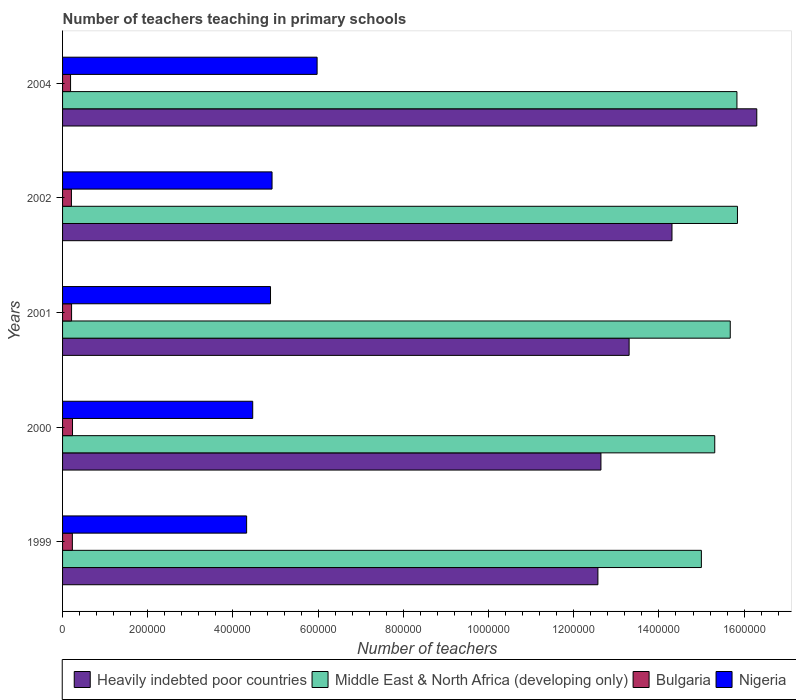Are the number of bars per tick equal to the number of legend labels?
Your answer should be very brief. Yes. Are the number of bars on each tick of the Y-axis equal?
Offer a very short reply. Yes. How many bars are there on the 3rd tick from the bottom?
Offer a very short reply. 4. What is the label of the 1st group of bars from the top?
Ensure brevity in your answer.  2004. In how many cases, is the number of bars for a given year not equal to the number of legend labels?
Your answer should be compact. 0. What is the number of teachers teaching in primary schools in Nigeria in 2004?
Keep it short and to the point. 5.98e+05. Across all years, what is the maximum number of teachers teaching in primary schools in Middle East & North Africa (developing only)?
Provide a succinct answer. 1.58e+06. Across all years, what is the minimum number of teachers teaching in primary schools in Nigeria?
Your answer should be compact. 4.32e+05. In which year was the number of teachers teaching in primary schools in Bulgaria maximum?
Offer a very short reply. 2000. In which year was the number of teachers teaching in primary schools in Heavily indebted poor countries minimum?
Your answer should be very brief. 1999. What is the total number of teachers teaching in primary schools in Nigeria in the graph?
Your response must be concise. 2.46e+06. What is the difference between the number of teachers teaching in primary schools in Middle East & North Africa (developing only) in 1999 and that in 2000?
Provide a succinct answer. -3.14e+04. What is the difference between the number of teachers teaching in primary schools in Middle East & North Africa (developing only) in 2004 and the number of teachers teaching in primary schools in Nigeria in 2001?
Your response must be concise. 1.09e+06. What is the average number of teachers teaching in primary schools in Bulgaria per year?
Offer a very short reply. 2.14e+04. In the year 2001, what is the difference between the number of teachers teaching in primary schools in Nigeria and number of teachers teaching in primary schools in Bulgaria?
Your response must be concise. 4.67e+05. What is the ratio of the number of teachers teaching in primary schools in Heavily indebted poor countries in 1999 to that in 2004?
Ensure brevity in your answer.  0.77. Is the number of teachers teaching in primary schools in Heavily indebted poor countries in 2000 less than that in 2004?
Provide a short and direct response. Yes. Is the difference between the number of teachers teaching in primary schools in Nigeria in 2000 and 2004 greater than the difference between the number of teachers teaching in primary schools in Bulgaria in 2000 and 2004?
Offer a terse response. No. What is the difference between the highest and the second highest number of teachers teaching in primary schools in Bulgaria?
Keep it short and to the point. 361. What is the difference between the highest and the lowest number of teachers teaching in primary schools in Middle East & North Africa (developing only)?
Give a very brief answer. 8.47e+04. In how many years, is the number of teachers teaching in primary schools in Bulgaria greater than the average number of teachers teaching in primary schools in Bulgaria taken over all years?
Keep it short and to the point. 2. What does the 4th bar from the top in 2000 represents?
Ensure brevity in your answer.  Heavily indebted poor countries. What does the 4th bar from the bottom in 2000 represents?
Your answer should be very brief. Nigeria. Is it the case that in every year, the sum of the number of teachers teaching in primary schools in Middle East & North Africa (developing only) and number of teachers teaching in primary schools in Nigeria is greater than the number of teachers teaching in primary schools in Heavily indebted poor countries?
Give a very brief answer. Yes. Does the graph contain grids?
Make the answer very short. No. Where does the legend appear in the graph?
Give a very brief answer. Bottom right. How many legend labels are there?
Provide a short and direct response. 4. What is the title of the graph?
Your answer should be very brief. Number of teachers teaching in primary schools. What is the label or title of the X-axis?
Provide a succinct answer. Number of teachers. What is the label or title of the Y-axis?
Offer a terse response. Years. What is the Number of teachers of Heavily indebted poor countries in 1999?
Offer a very short reply. 1.26e+06. What is the Number of teachers of Middle East & North Africa (developing only) in 1999?
Ensure brevity in your answer.  1.50e+06. What is the Number of teachers in Bulgaria in 1999?
Give a very brief answer. 2.30e+04. What is the Number of teachers of Nigeria in 1999?
Keep it short and to the point. 4.32e+05. What is the Number of teachers in Heavily indebted poor countries in 2000?
Provide a succinct answer. 1.26e+06. What is the Number of teachers in Middle East & North Africa (developing only) in 2000?
Provide a succinct answer. 1.53e+06. What is the Number of teachers in Bulgaria in 2000?
Provide a short and direct response. 2.33e+04. What is the Number of teachers of Nigeria in 2000?
Make the answer very short. 4.46e+05. What is the Number of teachers of Heavily indebted poor countries in 2001?
Give a very brief answer. 1.33e+06. What is the Number of teachers of Middle East & North Africa (developing only) in 2001?
Offer a very short reply. 1.57e+06. What is the Number of teachers in Bulgaria in 2001?
Your answer should be compact. 2.12e+04. What is the Number of teachers of Nigeria in 2001?
Your response must be concise. 4.88e+05. What is the Number of teachers of Heavily indebted poor countries in 2002?
Give a very brief answer. 1.43e+06. What is the Number of teachers of Middle East & North Africa (developing only) in 2002?
Give a very brief answer. 1.58e+06. What is the Number of teachers of Bulgaria in 2002?
Provide a short and direct response. 2.08e+04. What is the Number of teachers of Nigeria in 2002?
Offer a terse response. 4.92e+05. What is the Number of teachers in Heavily indebted poor countries in 2004?
Provide a succinct answer. 1.63e+06. What is the Number of teachers in Middle East & North Africa (developing only) in 2004?
Make the answer very short. 1.58e+06. What is the Number of teachers in Bulgaria in 2004?
Your answer should be compact. 1.88e+04. What is the Number of teachers in Nigeria in 2004?
Ensure brevity in your answer.  5.98e+05. Across all years, what is the maximum Number of teachers of Heavily indebted poor countries?
Ensure brevity in your answer.  1.63e+06. Across all years, what is the maximum Number of teachers in Middle East & North Africa (developing only)?
Your answer should be very brief. 1.58e+06. Across all years, what is the maximum Number of teachers in Bulgaria?
Provide a succinct answer. 2.33e+04. Across all years, what is the maximum Number of teachers of Nigeria?
Your answer should be compact. 5.98e+05. Across all years, what is the minimum Number of teachers of Heavily indebted poor countries?
Offer a terse response. 1.26e+06. Across all years, what is the minimum Number of teachers of Middle East & North Africa (developing only)?
Make the answer very short. 1.50e+06. Across all years, what is the minimum Number of teachers in Bulgaria?
Make the answer very short. 1.88e+04. Across all years, what is the minimum Number of teachers of Nigeria?
Make the answer very short. 4.32e+05. What is the total Number of teachers of Heavily indebted poor countries in the graph?
Your answer should be very brief. 6.91e+06. What is the total Number of teachers in Middle East & North Africa (developing only) in the graph?
Keep it short and to the point. 7.77e+06. What is the total Number of teachers of Bulgaria in the graph?
Your response must be concise. 1.07e+05. What is the total Number of teachers in Nigeria in the graph?
Keep it short and to the point. 2.46e+06. What is the difference between the Number of teachers of Heavily indebted poor countries in 1999 and that in 2000?
Give a very brief answer. -7112.5. What is the difference between the Number of teachers of Middle East & North Africa (developing only) in 1999 and that in 2000?
Your response must be concise. -3.14e+04. What is the difference between the Number of teachers in Bulgaria in 1999 and that in 2000?
Your answer should be compact. -361. What is the difference between the Number of teachers of Nigeria in 1999 and that in 2000?
Your response must be concise. -1.43e+04. What is the difference between the Number of teachers in Heavily indebted poor countries in 1999 and that in 2001?
Provide a short and direct response. -7.33e+04. What is the difference between the Number of teachers of Middle East & North Africa (developing only) in 1999 and that in 2001?
Make the answer very short. -6.78e+04. What is the difference between the Number of teachers of Bulgaria in 1999 and that in 2001?
Your answer should be very brief. 1822. What is the difference between the Number of teachers of Nigeria in 1999 and that in 2001?
Offer a terse response. -5.61e+04. What is the difference between the Number of teachers in Heavily indebted poor countries in 1999 and that in 2002?
Keep it short and to the point. -1.74e+05. What is the difference between the Number of teachers of Middle East & North Africa (developing only) in 1999 and that in 2002?
Offer a terse response. -8.47e+04. What is the difference between the Number of teachers in Bulgaria in 1999 and that in 2002?
Offer a very short reply. 2194. What is the difference between the Number of teachers in Nigeria in 1999 and that in 2002?
Your response must be concise. -5.97e+04. What is the difference between the Number of teachers in Heavily indebted poor countries in 1999 and that in 2004?
Give a very brief answer. -3.73e+05. What is the difference between the Number of teachers of Middle East & North Africa (developing only) in 1999 and that in 2004?
Provide a short and direct response. -8.35e+04. What is the difference between the Number of teachers in Bulgaria in 1999 and that in 2004?
Make the answer very short. 4221. What is the difference between the Number of teachers of Nigeria in 1999 and that in 2004?
Keep it short and to the point. -1.65e+05. What is the difference between the Number of teachers of Heavily indebted poor countries in 2000 and that in 2001?
Ensure brevity in your answer.  -6.62e+04. What is the difference between the Number of teachers of Middle East & North Africa (developing only) in 2000 and that in 2001?
Make the answer very short. -3.64e+04. What is the difference between the Number of teachers in Bulgaria in 2000 and that in 2001?
Give a very brief answer. 2183. What is the difference between the Number of teachers in Nigeria in 2000 and that in 2001?
Offer a very short reply. -4.18e+04. What is the difference between the Number of teachers of Heavily indebted poor countries in 2000 and that in 2002?
Offer a very short reply. -1.67e+05. What is the difference between the Number of teachers of Middle East & North Africa (developing only) in 2000 and that in 2002?
Give a very brief answer. -5.33e+04. What is the difference between the Number of teachers in Bulgaria in 2000 and that in 2002?
Ensure brevity in your answer.  2555. What is the difference between the Number of teachers of Nigeria in 2000 and that in 2002?
Provide a succinct answer. -4.53e+04. What is the difference between the Number of teachers of Heavily indebted poor countries in 2000 and that in 2004?
Your response must be concise. -3.66e+05. What is the difference between the Number of teachers in Middle East & North Africa (developing only) in 2000 and that in 2004?
Keep it short and to the point. -5.21e+04. What is the difference between the Number of teachers of Bulgaria in 2000 and that in 2004?
Your answer should be very brief. 4582. What is the difference between the Number of teachers of Nigeria in 2000 and that in 2004?
Offer a very short reply. -1.51e+05. What is the difference between the Number of teachers of Heavily indebted poor countries in 2001 and that in 2002?
Your response must be concise. -1.01e+05. What is the difference between the Number of teachers of Middle East & North Africa (developing only) in 2001 and that in 2002?
Offer a very short reply. -1.69e+04. What is the difference between the Number of teachers of Bulgaria in 2001 and that in 2002?
Provide a succinct answer. 372. What is the difference between the Number of teachers of Nigeria in 2001 and that in 2002?
Provide a short and direct response. -3587. What is the difference between the Number of teachers in Heavily indebted poor countries in 2001 and that in 2004?
Provide a succinct answer. -3.00e+05. What is the difference between the Number of teachers of Middle East & North Africa (developing only) in 2001 and that in 2004?
Provide a succinct answer. -1.57e+04. What is the difference between the Number of teachers of Bulgaria in 2001 and that in 2004?
Keep it short and to the point. 2399. What is the difference between the Number of teachers of Nigeria in 2001 and that in 2004?
Keep it short and to the point. -1.09e+05. What is the difference between the Number of teachers in Heavily indebted poor countries in 2002 and that in 2004?
Keep it short and to the point. -1.99e+05. What is the difference between the Number of teachers of Middle East & North Africa (developing only) in 2002 and that in 2004?
Ensure brevity in your answer.  1215. What is the difference between the Number of teachers in Bulgaria in 2002 and that in 2004?
Keep it short and to the point. 2027. What is the difference between the Number of teachers in Nigeria in 2002 and that in 2004?
Make the answer very short. -1.06e+05. What is the difference between the Number of teachers of Heavily indebted poor countries in 1999 and the Number of teachers of Middle East & North Africa (developing only) in 2000?
Keep it short and to the point. -2.74e+05. What is the difference between the Number of teachers of Heavily indebted poor countries in 1999 and the Number of teachers of Bulgaria in 2000?
Ensure brevity in your answer.  1.23e+06. What is the difference between the Number of teachers of Heavily indebted poor countries in 1999 and the Number of teachers of Nigeria in 2000?
Your answer should be compact. 8.10e+05. What is the difference between the Number of teachers of Middle East & North Africa (developing only) in 1999 and the Number of teachers of Bulgaria in 2000?
Provide a succinct answer. 1.48e+06. What is the difference between the Number of teachers of Middle East & North Africa (developing only) in 1999 and the Number of teachers of Nigeria in 2000?
Your response must be concise. 1.05e+06. What is the difference between the Number of teachers of Bulgaria in 1999 and the Number of teachers of Nigeria in 2000?
Provide a short and direct response. -4.23e+05. What is the difference between the Number of teachers in Heavily indebted poor countries in 1999 and the Number of teachers in Middle East & North Africa (developing only) in 2001?
Your answer should be very brief. -3.11e+05. What is the difference between the Number of teachers in Heavily indebted poor countries in 1999 and the Number of teachers in Bulgaria in 2001?
Ensure brevity in your answer.  1.24e+06. What is the difference between the Number of teachers of Heavily indebted poor countries in 1999 and the Number of teachers of Nigeria in 2001?
Offer a terse response. 7.69e+05. What is the difference between the Number of teachers in Middle East & North Africa (developing only) in 1999 and the Number of teachers in Bulgaria in 2001?
Make the answer very short. 1.48e+06. What is the difference between the Number of teachers of Middle East & North Africa (developing only) in 1999 and the Number of teachers of Nigeria in 2001?
Give a very brief answer. 1.01e+06. What is the difference between the Number of teachers of Bulgaria in 1999 and the Number of teachers of Nigeria in 2001?
Make the answer very short. -4.65e+05. What is the difference between the Number of teachers in Heavily indebted poor countries in 1999 and the Number of teachers in Middle East & North Africa (developing only) in 2002?
Your answer should be very brief. -3.28e+05. What is the difference between the Number of teachers of Heavily indebted poor countries in 1999 and the Number of teachers of Bulgaria in 2002?
Provide a succinct answer. 1.24e+06. What is the difference between the Number of teachers in Heavily indebted poor countries in 1999 and the Number of teachers in Nigeria in 2002?
Offer a terse response. 7.65e+05. What is the difference between the Number of teachers of Middle East & North Africa (developing only) in 1999 and the Number of teachers of Bulgaria in 2002?
Give a very brief answer. 1.48e+06. What is the difference between the Number of teachers in Middle East & North Africa (developing only) in 1999 and the Number of teachers in Nigeria in 2002?
Your answer should be compact. 1.01e+06. What is the difference between the Number of teachers of Bulgaria in 1999 and the Number of teachers of Nigeria in 2002?
Your response must be concise. -4.69e+05. What is the difference between the Number of teachers of Heavily indebted poor countries in 1999 and the Number of teachers of Middle East & North Africa (developing only) in 2004?
Keep it short and to the point. -3.26e+05. What is the difference between the Number of teachers in Heavily indebted poor countries in 1999 and the Number of teachers in Bulgaria in 2004?
Offer a very short reply. 1.24e+06. What is the difference between the Number of teachers in Heavily indebted poor countries in 1999 and the Number of teachers in Nigeria in 2004?
Provide a short and direct response. 6.59e+05. What is the difference between the Number of teachers in Middle East & North Africa (developing only) in 1999 and the Number of teachers in Bulgaria in 2004?
Ensure brevity in your answer.  1.48e+06. What is the difference between the Number of teachers in Middle East & North Africa (developing only) in 1999 and the Number of teachers in Nigeria in 2004?
Keep it short and to the point. 9.02e+05. What is the difference between the Number of teachers in Bulgaria in 1999 and the Number of teachers in Nigeria in 2004?
Make the answer very short. -5.75e+05. What is the difference between the Number of teachers in Heavily indebted poor countries in 2000 and the Number of teachers in Middle East & North Africa (developing only) in 2001?
Offer a very short reply. -3.04e+05. What is the difference between the Number of teachers of Heavily indebted poor countries in 2000 and the Number of teachers of Bulgaria in 2001?
Make the answer very short. 1.24e+06. What is the difference between the Number of teachers of Heavily indebted poor countries in 2000 and the Number of teachers of Nigeria in 2001?
Make the answer very short. 7.76e+05. What is the difference between the Number of teachers in Middle East & North Africa (developing only) in 2000 and the Number of teachers in Bulgaria in 2001?
Offer a very short reply. 1.51e+06. What is the difference between the Number of teachers in Middle East & North Africa (developing only) in 2000 and the Number of teachers in Nigeria in 2001?
Provide a succinct answer. 1.04e+06. What is the difference between the Number of teachers of Bulgaria in 2000 and the Number of teachers of Nigeria in 2001?
Offer a terse response. -4.65e+05. What is the difference between the Number of teachers in Heavily indebted poor countries in 2000 and the Number of teachers in Middle East & North Africa (developing only) in 2002?
Ensure brevity in your answer.  -3.20e+05. What is the difference between the Number of teachers of Heavily indebted poor countries in 2000 and the Number of teachers of Bulgaria in 2002?
Your response must be concise. 1.24e+06. What is the difference between the Number of teachers of Heavily indebted poor countries in 2000 and the Number of teachers of Nigeria in 2002?
Your response must be concise. 7.72e+05. What is the difference between the Number of teachers of Middle East & North Africa (developing only) in 2000 and the Number of teachers of Bulgaria in 2002?
Offer a very short reply. 1.51e+06. What is the difference between the Number of teachers in Middle East & North Africa (developing only) in 2000 and the Number of teachers in Nigeria in 2002?
Offer a very short reply. 1.04e+06. What is the difference between the Number of teachers of Bulgaria in 2000 and the Number of teachers of Nigeria in 2002?
Give a very brief answer. -4.68e+05. What is the difference between the Number of teachers of Heavily indebted poor countries in 2000 and the Number of teachers of Middle East & North Africa (developing only) in 2004?
Your answer should be compact. -3.19e+05. What is the difference between the Number of teachers of Heavily indebted poor countries in 2000 and the Number of teachers of Bulgaria in 2004?
Make the answer very short. 1.25e+06. What is the difference between the Number of teachers of Heavily indebted poor countries in 2000 and the Number of teachers of Nigeria in 2004?
Offer a very short reply. 6.66e+05. What is the difference between the Number of teachers in Middle East & North Africa (developing only) in 2000 and the Number of teachers in Bulgaria in 2004?
Your response must be concise. 1.51e+06. What is the difference between the Number of teachers in Middle East & North Africa (developing only) in 2000 and the Number of teachers in Nigeria in 2004?
Provide a succinct answer. 9.33e+05. What is the difference between the Number of teachers of Bulgaria in 2000 and the Number of teachers of Nigeria in 2004?
Your answer should be compact. -5.74e+05. What is the difference between the Number of teachers in Heavily indebted poor countries in 2001 and the Number of teachers in Middle East & North Africa (developing only) in 2002?
Keep it short and to the point. -2.54e+05. What is the difference between the Number of teachers in Heavily indebted poor countries in 2001 and the Number of teachers in Bulgaria in 2002?
Your response must be concise. 1.31e+06. What is the difference between the Number of teachers in Heavily indebted poor countries in 2001 and the Number of teachers in Nigeria in 2002?
Provide a succinct answer. 8.38e+05. What is the difference between the Number of teachers in Middle East & North Africa (developing only) in 2001 and the Number of teachers in Bulgaria in 2002?
Your answer should be compact. 1.55e+06. What is the difference between the Number of teachers in Middle East & North Africa (developing only) in 2001 and the Number of teachers in Nigeria in 2002?
Provide a succinct answer. 1.08e+06. What is the difference between the Number of teachers in Bulgaria in 2001 and the Number of teachers in Nigeria in 2002?
Make the answer very short. -4.71e+05. What is the difference between the Number of teachers of Heavily indebted poor countries in 2001 and the Number of teachers of Middle East & North Africa (developing only) in 2004?
Your answer should be compact. -2.53e+05. What is the difference between the Number of teachers in Heavily indebted poor countries in 2001 and the Number of teachers in Bulgaria in 2004?
Your answer should be very brief. 1.31e+06. What is the difference between the Number of teachers in Heavily indebted poor countries in 2001 and the Number of teachers in Nigeria in 2004?
Your response must be concise. 7.32e+05. What is the difference between the Number of teachers of Middle East & North Africa (developing only) in 2001 and the Number of teachers of Bulgaria in 2004?
Provide a succinct answer. 1.55e+06. What is the difference between the Number of teachers in Middle East & North Africa (developing only) in 2001 and the Number of teachers in Nigeria in 2004?
Ensure brevity in your answer.  9.70e+05. What is the difference between the Number of teachers in Bulgaria in 2001 and the Number of teachers in Nigeria in 2004?
Your response must be concise. -5.76e+05. What is the difference between the Number of teachers of Heavily indebted poor countries in 2002 and the Number of teachers of Middle East & North Africa (developing only) in 2004?
Your answer should be compact. -1.52e+05. What is the difference between the Number of teachers of Heavily indebted poor countries in 2002 and the Number of teachers of Bulgaria in 2004?
Ensure brevity in your answer.  1.41e+06. What is the difference between the Number of teachers of Heavily indebted poor countries in 2002 and the Number of teachers of Nigeria in 2004?
Your answer should be compact. 8.33e+05. What is the difference between the Number of teachers of Middle East & North Africa (developing only) in 2002 and the Number of teachers of Bulgaria in 2004?
Your response must be concise. 1.57e+06. What is the difference between the Number of teachers of Middle East & North Africa (developing only) in 2002 and the Number of teachers of Nigeria in 2004?
Your response must be concise. 9.87e+05. What is the difference between the Number of teachers of Bulgaria in 2002 and the Number of teachers of Nigeria in 2004?
Offer a very short reply. -5.77e+05. What is the average Number of teachers of Heavily indebted poor countries per year?
Provide a short and direct response. 1.38e+06. What is the average Number of teachers of Middle East & North Africa (developing only) per year?
Offer a very short reply. 1.55e+06. What is the average Number of teachers in Bulgaria per year?
Provide a succinct answer. 2.14e+04. What is the average Number of teachers in Nigeria per year?
Your response must be concise. 4.91e+05. In the year 1999, what is the difference between the Number of teachers of Heavily indebted poor countries and Number of teachers of Middle East & North Africa (developing only)?
Your answer should be compact. -2.43e+05. In the year 1999, what is the difference between the Number of teachers of Heavily indebted poor countries and Number of teachers of Bulgaria?
Offer a very short reply. 1.23e+06. In the year 1999, what is the difference between the Number of teachers in Heavily indebted poor countries and Number of teachers in Nigeria?
Your answer should be compact. 8.25e+05. In the year 1999, what is the difference between the Number of teachers in Middle East & North Africa (developing only) and Number of teachers in Bulgaria?
Your answer should be compact. 1.48e+06. In the year 1999, what is the difference between the Number of teachers of Middle East & North Africa (developing only) and Number of teachers of Nigeria?
Provide a short and direct response. 1.07e+06. In the year 1999, what is the difference between the Number of teachers of Bulgaria and Number of teachers of Nigeria?
Keep it short and to the point. -4.09e+05. In the year 2000, what is the difference between the Number of teachers of Heavily indebted poor countries and Number of teachers of Middle East & North Africa (developing only)?
Offer a terse response. -2.67e+05. In the year 2000, what is the difference between the Number of teachers of Heavily indebted poor countries and Number of teachers of Bulgaria?
Keep it short and to the point. 1.24e+06. In the year 2000, what is the difference between the Number of teachers of Heavily indebted poor countries and Number of teachers of Nigeria?
Provide a short and direct response. 8.17e+05. In the year 2000, what is the difference between the Number of teachers of Middle East & North Africa (developing only) and Number of teachers of Bulgaria?
Your answer should be very brief. 1.51e+06. In the year 2000, what is the difference between the Number of teachers in Middle East & North Africa (developing only) and Number of teachers in Nigeria?
Make the answer very short. 1.08e+06. In the year 2000, what is the difference between the Number of teachers of Bulgaria and Number of teachers of Nigeria?
Offer a terse response. -4.23e+05. In the year 2001, what is the difference between the Number of teachers in Heavily indebted poor countries and Number of teachers in Middle East & North Africa (developing only)?
Offer a terse response. -2.37e+05. In the year 2001, what is the difference between the Number of teachers of Heavily indebted poor countries and Number of teachers of Bulgaria?
Keep it short and to the point. 1.31e+06. In the year 2001, what is the difference between the Number of teachers in Heavily indebted poor countries and Number of teachers in Nigeria?
Offer a very short reply. 8.42e+05. In the year 2001, what is the difference between the Number of teachers in Middle East & North Africa (developing only) and Number of teachers in Bulgaria?
Your response must be concise. 1.55e+06. In the year 2001, what is the difference between the Number of teachers of Middle East & North Africa (developing only) and Number of teachers of Nigeria?
Your answer should be very brief. 1.08e+06. In the year 2001, what is the difference between the Number of teachers of Bulgaria and Number of teachers of Nigeria?
Your answer should be very brief. -4.67e+05. In the year 2002, what is the difference between the Number of teachers of Heavily indebted poor countries and Number of teachers of Middle East & North Africa (developing only)?
Your response must be concise. -1.54e+05. In the year 2002, what is the difference between the Number of teachers in Heavily indebted poor countries and Number of teachers in Bulgaria?
Offer a terse response. 1.41e+06. In the year 2002, what is the difference between the Number of teachers of Heavily indebted poor countries and Number of teachers of Nigeria?
Offer a terse response. 9.39e+05. In the year 2002, what is the difference between the Number of teachers of Middle East & North Africa (developing only) and Number of teachers of Bulgaria?
Make the answer very short. 1.56e+06. In the year 2002, what is the difference between the Number of teachers of Middle East & North Africa (developing only) and Number of teachers of Nigeria?
Make the answer very short. 1.09e+06. In the year 2002, what is the difference between the Number of teachers of Bulgaria and Number of teachers of Nigeria?
Your response must be concise. -4.71e+05. In the year 2004, what is the difference between the Number of teachers in Heavily indebted poor countries and Number of teachers in Middle East & North Africa (developing only)?
Provide a succinct answer. 4.66e+04. In the year 2004, what is the difference between the Number of teachers in Heavily indebted poor countries and Number of teachers in Bulgaria?
Keep it short and to the point. 1.61e+06. In the year 2004, what is the difference between the Number of teachers in Heavily indebted poor countries and Number of teachers in Nigeria?
Provide a short and direct response. 1.03e+06. In the year 2004, what is the difference between the Number of teachers of Middle East & North Africa (developing only) and Number of teachers of Bulgaria?
Your answer should be very brief. 1.56e+06. In the year 2004, what is the difference between the Number of teachers in Middle East & North Africa (developing only) and Number of teachers in Nigeria?
Your answer should be compact. 9.86e+05. In the year 2004, what is the difference between the Number of teachers of Bulgaria and Number of teachers of Nigeria?
Ensure brevity in your answer.  -5.79e+05. What is the ratio of the Number of teachers in Heavily indebted poor countries in 1999 to that in 2000?
Make the answer very short. 0.99. What is the ratio of the Number of teachers of Middle East & North Africa (developing only) in 1999 to that in 2000?
Keep it short and to the point. 0.98. What is the ratio of the Number of teachers of Bulgaria in 1999 to that in 2000?
Your answer should be compact. 0.98. What is the ratio of the Number of teachers of Nigeria in 1999 to that in 2000?
Offer a very short reply. 0.97. What is the ratio of the Number of teachers in Heavily indebted poor countries in 1999 to that in 2001?
Ensure brevity in your answer.  0.94. What is the ratio of the Number of teachers of Middle East & North Africa (developing only) in 1999 to that in 2001?
Your answer should be very brief. 0.96. What is the ratio of the Number of teachers in Bulgaria in 1999 to that in 2001?
Your answer should be very brief. 1.09. What is the ratio of the Number of teachers of Nigeria in 1999 to that in 2001?
Offer a terse response. 0.89. What is the ratio of the Number of teachers in Heavily indebted poor countries in 1999 to that in 2002?
Make the answer very short. 0.88. What is the ratio of the Number of teachers in Middle East & North Africa (developing only) in 1999 to that in 2002?
Give a very brief answer. 0.95. What is the ratio of the Number of teachers of Bulgaria in 1999 to that in 2002?
Give a very brief answer. 1.11. What is the ratio of the Number of teachers in Nigeria in 1999 to that in 2002?
Your response must be concise. 0.88. What is the ratio of the Number of teachers in Heavily indebted poor countries in 1999 to that in 2004?
Give a very brief answer. 0.77. What is the ratio of the Number of teachers of Middle East & North Africa (developing only) in 1999 to that in 2004?
Provide a succinct answer. 0.95. What is the ratio of the Number of teachers of Bulgaria in 1999 to that in 2004?
Give a very brief answer. 1.23. What is the ratio of the Number of teachers of Nigeria in 1999 to that in 2004?
Your answer should be very brief. 0.72. What is the ratio of the Number of teachers of Heavily indebted poor countries in 2000 to that in 2001?
Ensure brevity in your answer.  0.95. What is the ratio of the Number of teachers of Middle East & North Africa (developing only) in 2000 to that in 2001?
Keep it short and to the point. 0.98. What is the ratio of the Number of teachers of Bulgaria in 2000 to that in 2001?
Ensure brevity in your answer.  1.1. What is the ratio of the Number of teachers of Nigeria in 2000 to that in 2001?
Give a very brief answer. 0.91. What is the ratio of the Number of teachers in Heavily indebted poor countries in 2000 to that in 2002?
Your answer should be compact. 0.88. What is the ratio of the Number of teachers in Middle East & North Africa (developing only) in 2000 to that in 2002?
Offer a terse response. 0.97. What is the ratio of the Number of teachers in Bulgaria in 2000 to that in 2002?
Offer a terse response. 1.12. What is the ratio of the Number of teachers of Nigeria in 2000 to that in 2002?
Offer a terse response. 0.91. What is the ratio of the Number of teachers in Heavily indebted poor countries in 2000 to that in 2004?
Give a very brief answer. 0.78. What is the ratio of the Number of teachers of Middle East & North Africa (developing only) in 2000 to that in 2004?
Your answer should be compact. 0.97. What is the ratio of the Number of teachers in Bulgaria in 2000 to that in 2004?
Provide a short and direct response. 1.24. What is the ratio of the Number of teachers of Nigeria in 2000 to that in 2004?
Your response must be concise. 0.75. What is the ratio of the Number of teachers in Heavily indebted poor countries in 2001 to that in 2002?
Give a very brief answer. 0.93. What is the ratio of the Number of teachers of Middle East & North Africa (developing only) in 2001 to that in 2002?
Ensure brevity in your answer.  0.99. What is the ratio of the Number of teachers in Bulgaria in 2001 to that in 2002?
Give a very brief answer. 1.02. What is the ratio of the Number of teachers in Heavily indebted poor countries in 2001 to that in 2004?
Your answer should be compact. 0.82. What is the ratio of the Number of teachers in Middle East & North Africa (developing only) in 2001 to that in 2004?
Give a very brief answer. 0.99. What is the ratio of the Number of teachers in Bulgaria in 2001 to that in 2004?
Ensure brevity in your answer.  1.13. What is the ratio of the Number of teachers of Nigeria in 2001 to that in 2004?
Offer a very short reply. 0.82. What is the ratio of the Number of teachers in Heavily indebted poor countries in 2002 to that in 2004?
Make the answer very short. 0.88. What is the ratio of the Number of teachers in Middle East & North Africa (developing only) in 2002 to that in 2004?
Keep it short and to the point. 1. What is the ratio of the Number of teachers in Bulgaria in 2002 to that in 2004?
Provide a short and direct response. 1.11. What is the ratio of the Number of teachers in Nigeria in 2002 to that in 2004?
Make the answer very short. 0.82. What is the difference between the highest and the second highest Number of teachers in Heavily indebted poor countries?
Provide a short and direct response. 1.99e+05. What is the difference between the highest and the second highest Number of teachers of Middle East & North Africa (developing only)?
Your answer should be compact. 1215. What is the difference between the highest and the second highest Number of teachers in Bulgaria?
Ensure brevity in your answer.  361. What is the difference between the highest and the second highest Number of teachers in Nigeria?
Make the answer very short. 1.06e+05. What is the difference between the highest and the lowest Number of teachers of Heavily indebted poor countries?
Keep it short and to the point. 3.73e+05. What is the difference between the highest and the lowest Number of teachers in Middle East & North Africa (developing only)?
Your response must be concise. 8.47e+04. What is the difference between the highest and the lowest Number of teachers in Bulgaria?
Your response must be concise. 4582. What is the difference between the highest and the lowest Number of teachers in Nigeria?
Keep it short and to the point. 1.65e+05. 